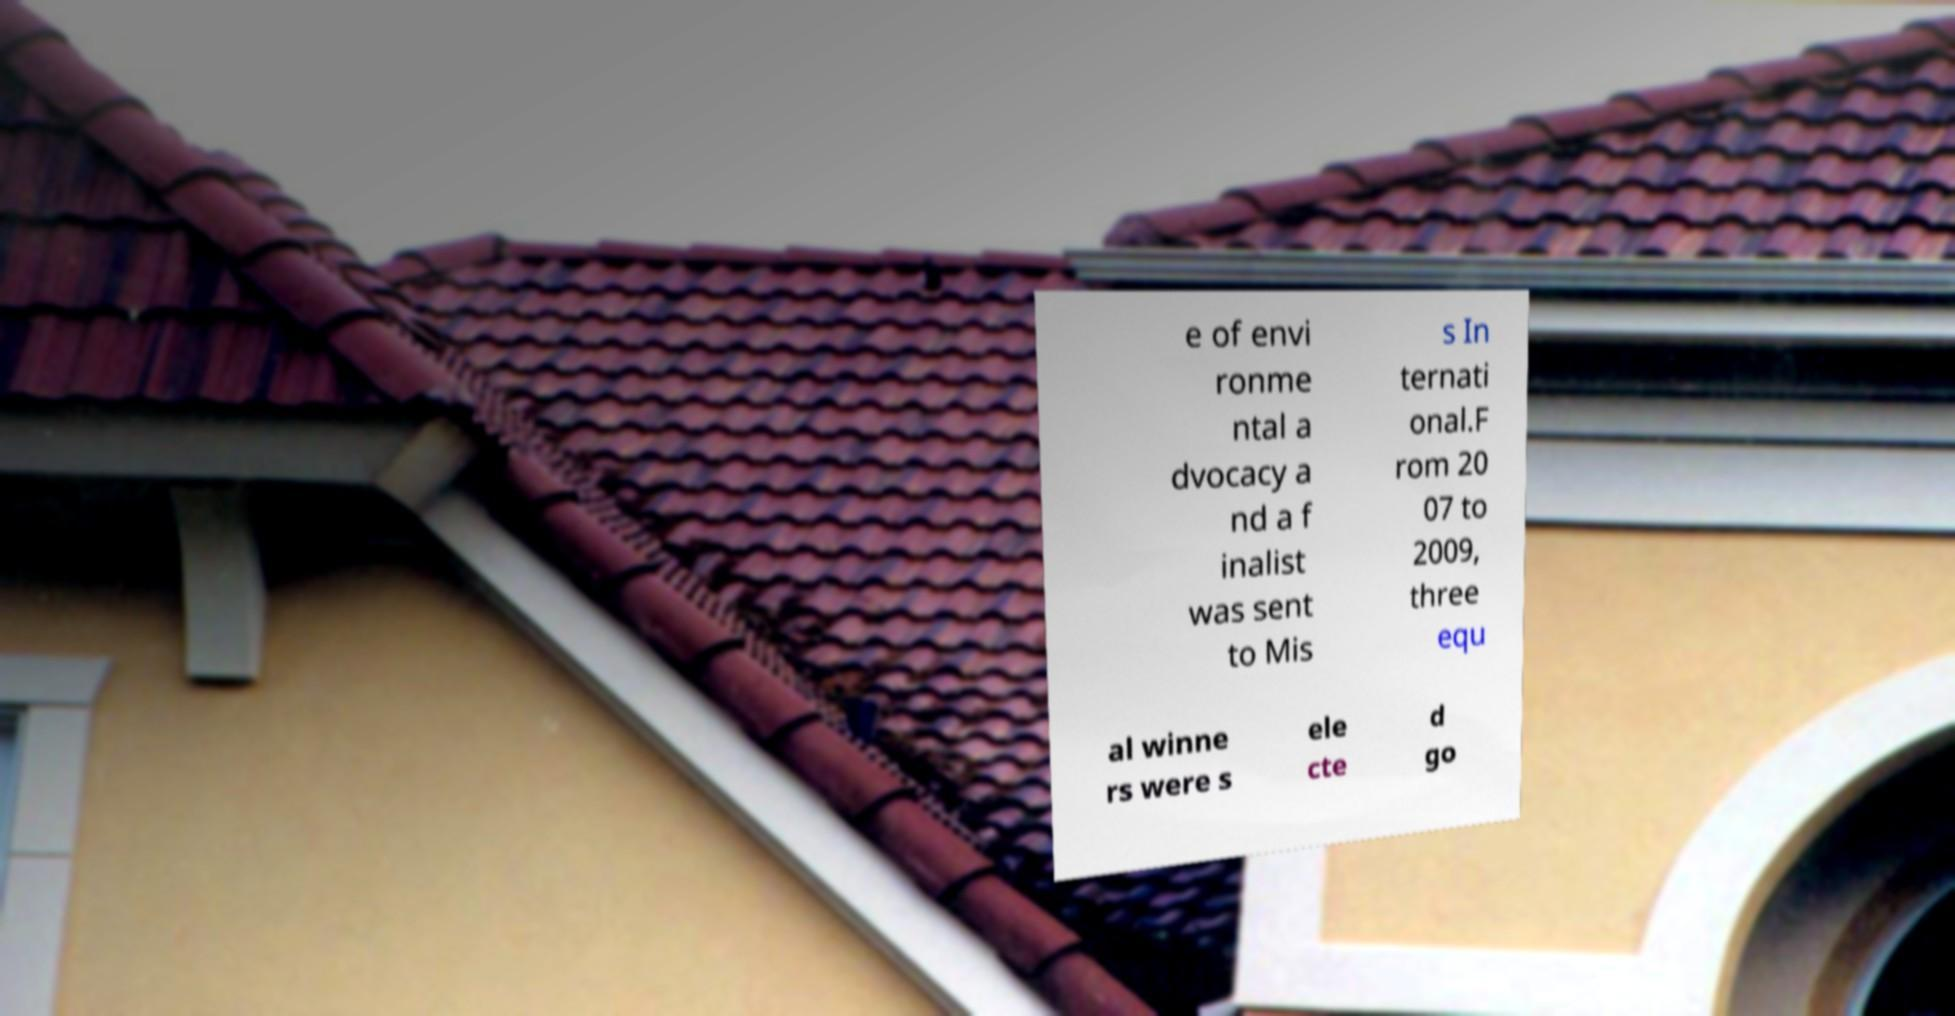I need the written content from this picture converted into text. Can you do that? e of envi ronme ntal a dvocacy a nd a f inalist was sent to Mis s In ternati onal.F rom 20 07 to 2009, three equ al winne rs were s ele cte d go 